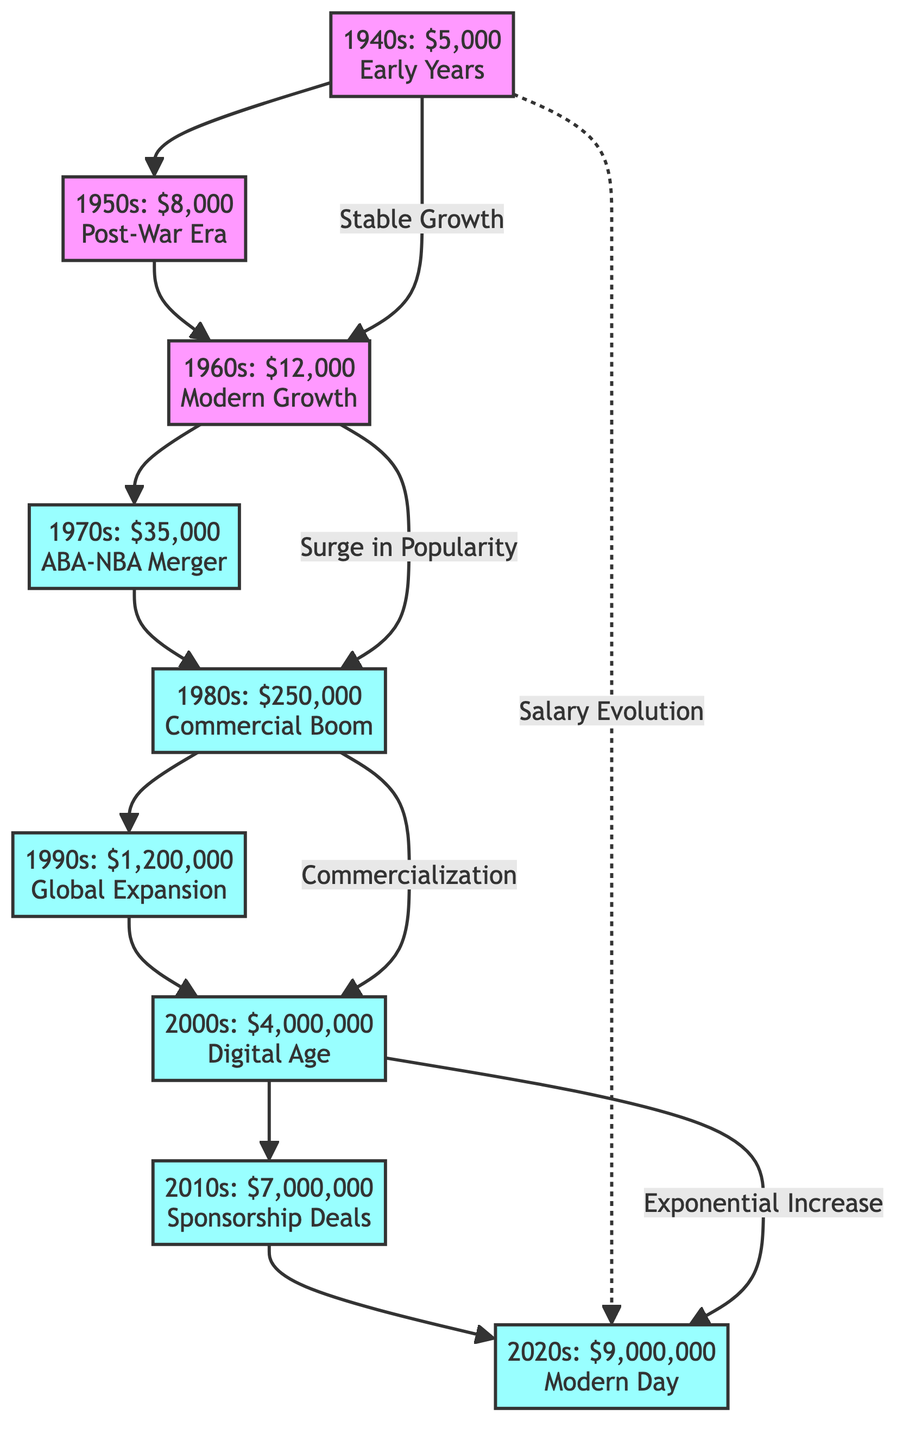What is the salary in the 1980s? The diagram specifically lists the salary for the 1980s as $250,000. This information is directly obtained from the node labeled "1980s: $250,000".
Answer: $250,000 Which decade saw a salary increase from $1,200,000 to $4,000,000? To find the decade with this salary increase, we track the flow: $1,200,000 (1990s) flows to $4,000,000 (2000s). Thus, the decade that has this increase is the 1990s to the 2000s.
Answer: 1990s What was the salary growth trend between the 1960s and 1980s? The trend from the 1960s ($12,000) to the 1980s ($250,000) represents a significant surge, as indicated by the label "Surge in Popularity" connecting these nodes. Taking note of the numerical increase confirms the overall growth.
Answer: Surge in Popularity How many decades are represented in the diagram? We count each decade node in the diagram from the 1940s to the 2020s. The nodes are: 1940s, 1950s, 1960s, 1970s, 1980s, 1990s, 2000s, 2010s, and 2020s, making it a total of nine decades.
Answer: 9 What is the salary in the 2020s? According to the diagram, the salary noted for the 2020s is $9,000,000 as directly stated in the node labeled "2020s: $9,000,000".
Answer: $9,000,000 What connection is described as "Exponential Increase"? The "Exponential Increase" phrase connects the 2000s ($4,000,000) to the 2020s ($9,000,000). This label implies a rapid growth trend in the given time period.
Answer: Exponential Increase Which decade experienced "Commercialization"? Following the diagram, this phenomenon is indicated by the node connection between the 1980s and 2000s. It shows that the 1980s led into the commercialization of salaries in the 2000s.
Answer: 1980s What was the salary in the 1940s? The diagram explicitly states that the salary in the 1940s is $5,000, located at the beginning node labeled "1940s: $5,000".
Answer: $5,000 